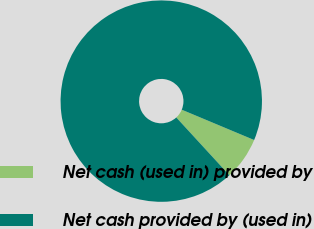<chart> <loc_0><loc_0><loc_500><loc_500><pie_chart><fcel>Net cash (used in) provided by<fcel>Net cash provided by (used in)<nl><fcel>6.86%<fcel>93.14%<nl></chart> 